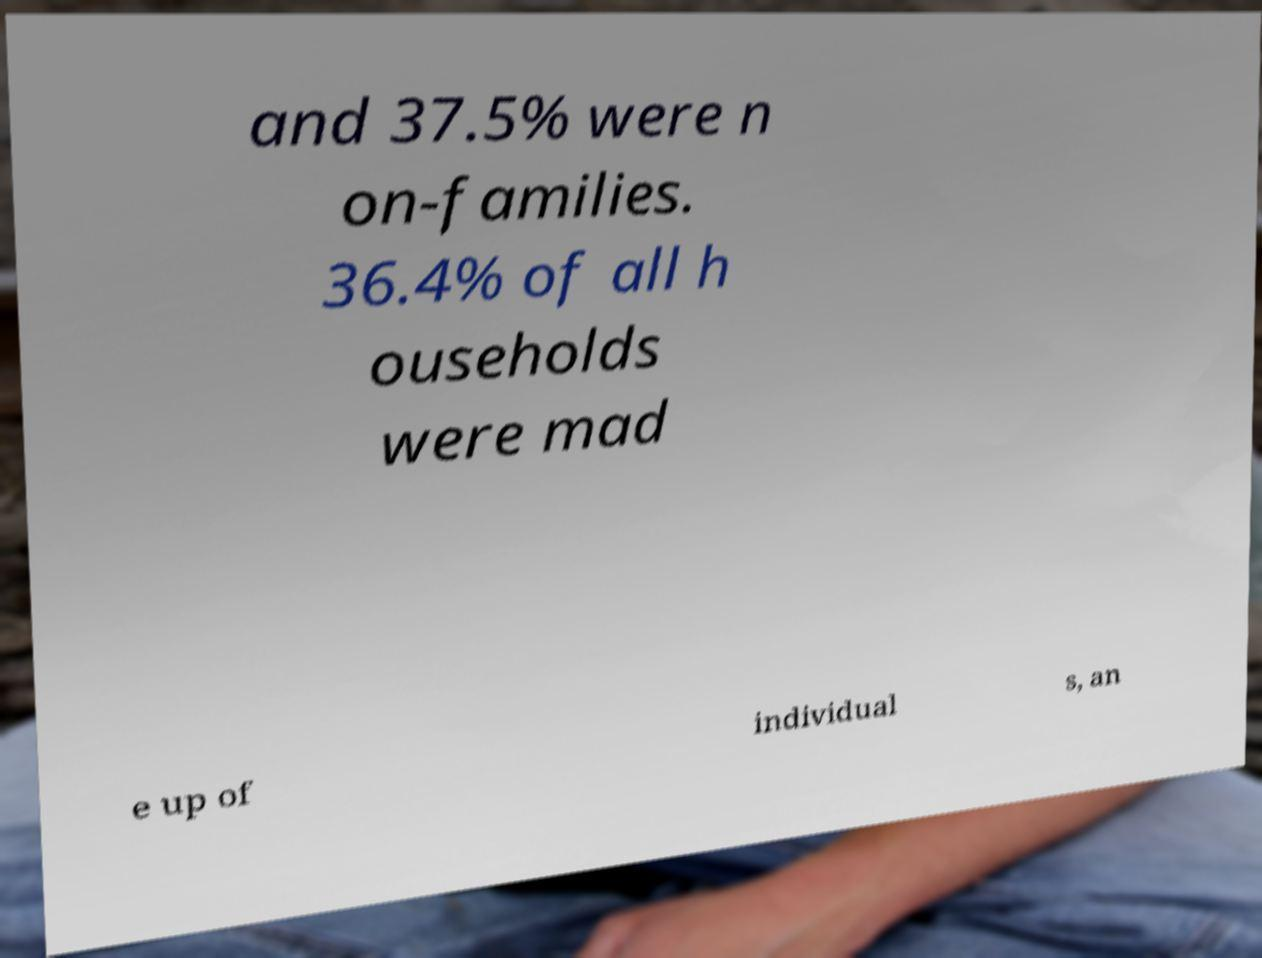Could you assist in decoding the text presented in this image and type it out clearly? and 37.5% were n on-families. 36.4% of all h ouseholds were mad e up of individual s, an 